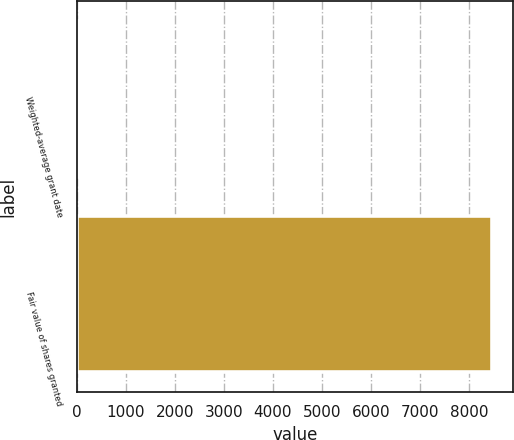Convert chart to OTSL. <chart><loc_0><loc_0><loc_500><loc_500><bar_chart><fcel>Weighted-average grant date<fcel>Fair value of shares granted<nl><fcel>58.23<fcel>8463<nl></chart> 